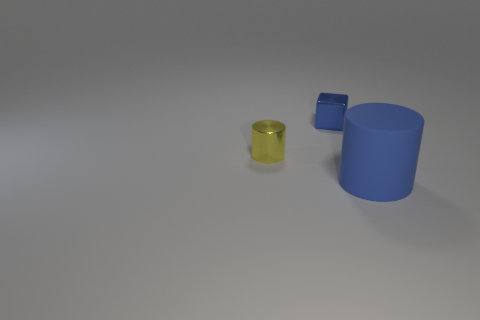Add 2 small red shiny things. How many objects exist? 5 Add 3 large purple cubes. How many large purple cubes exist? 3 Subtract 0 yellow cubes. How many objects are left? 3 Subtract all cubes. How many objects are left? 2 Subtract 1 cubes. How many cubes are left? 0 Subtract all tiny red cylinders. Subtract all tiny metallic cylinders. How many objects are left? 2 Add 1 metallic objects. How many metallic objects are left? 3 